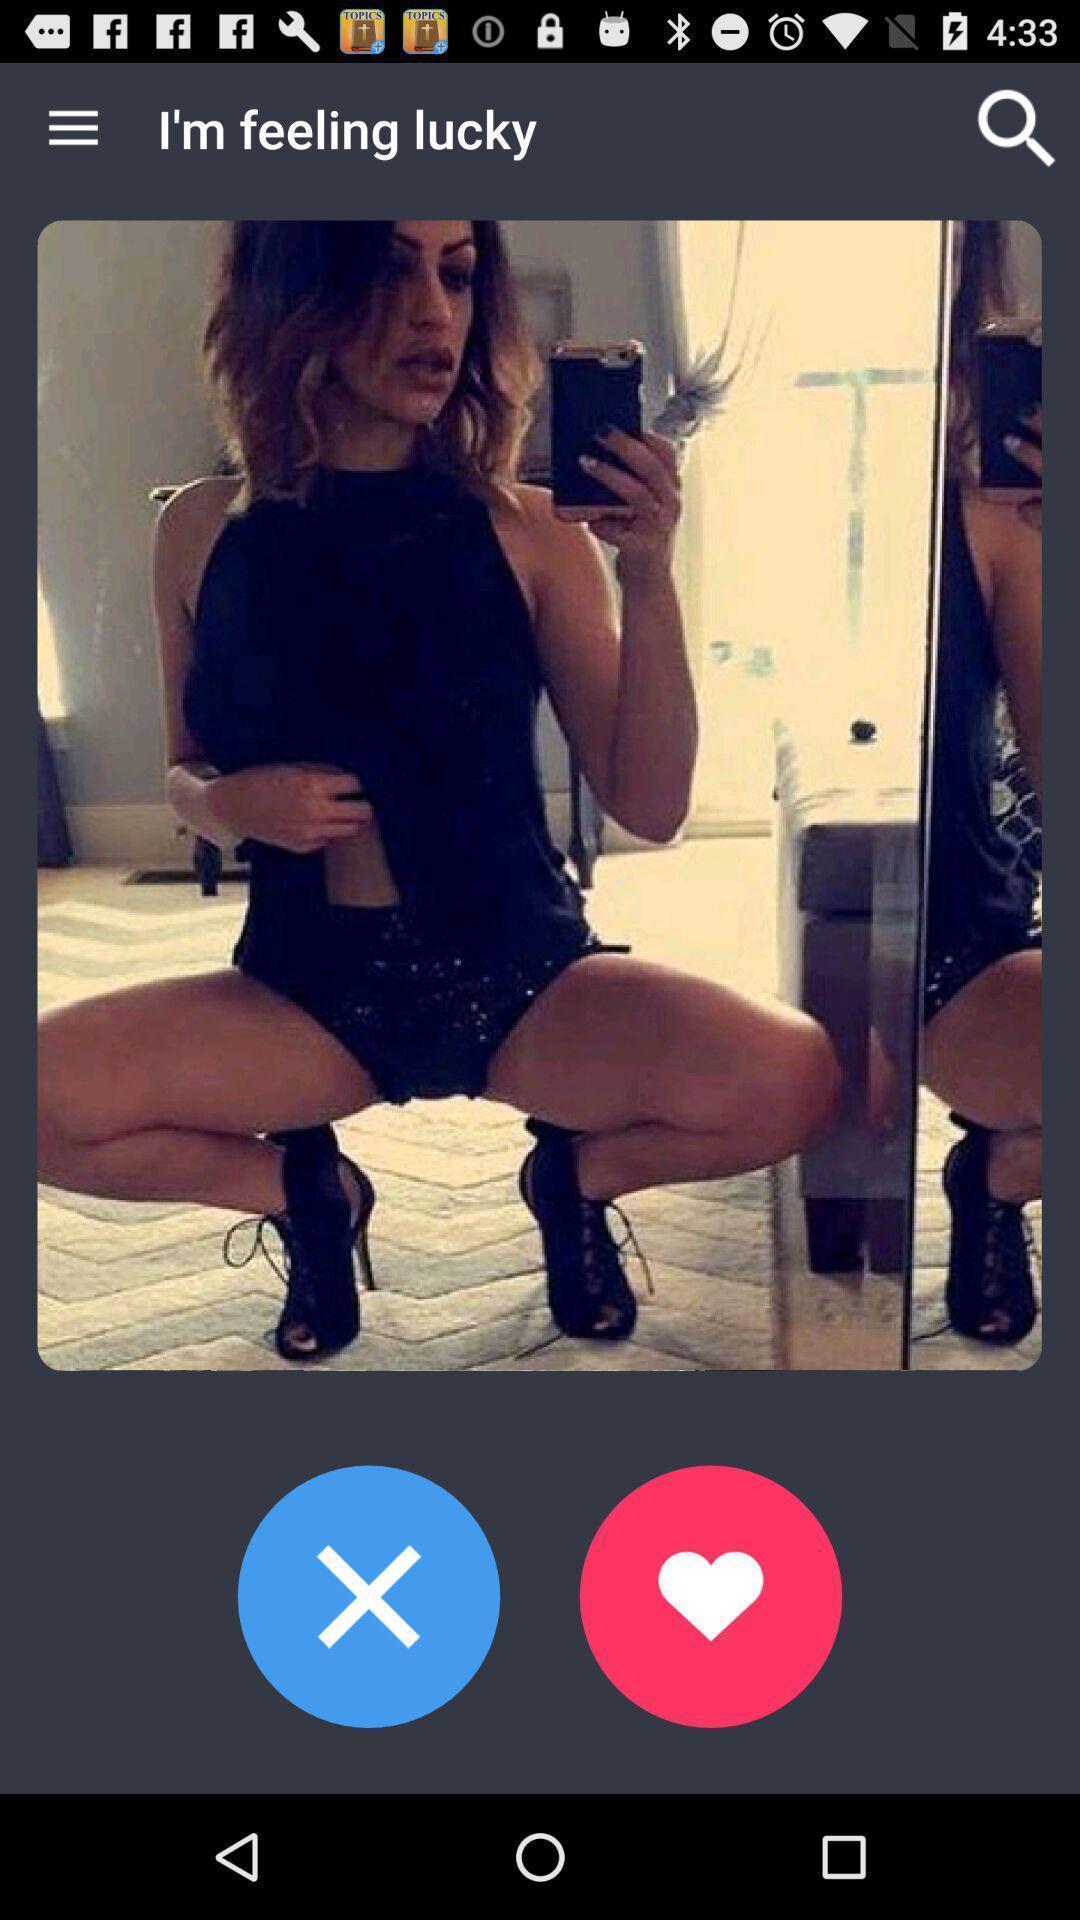Explain what's happening in this screen capture. Screen shows a picture of a lady. 